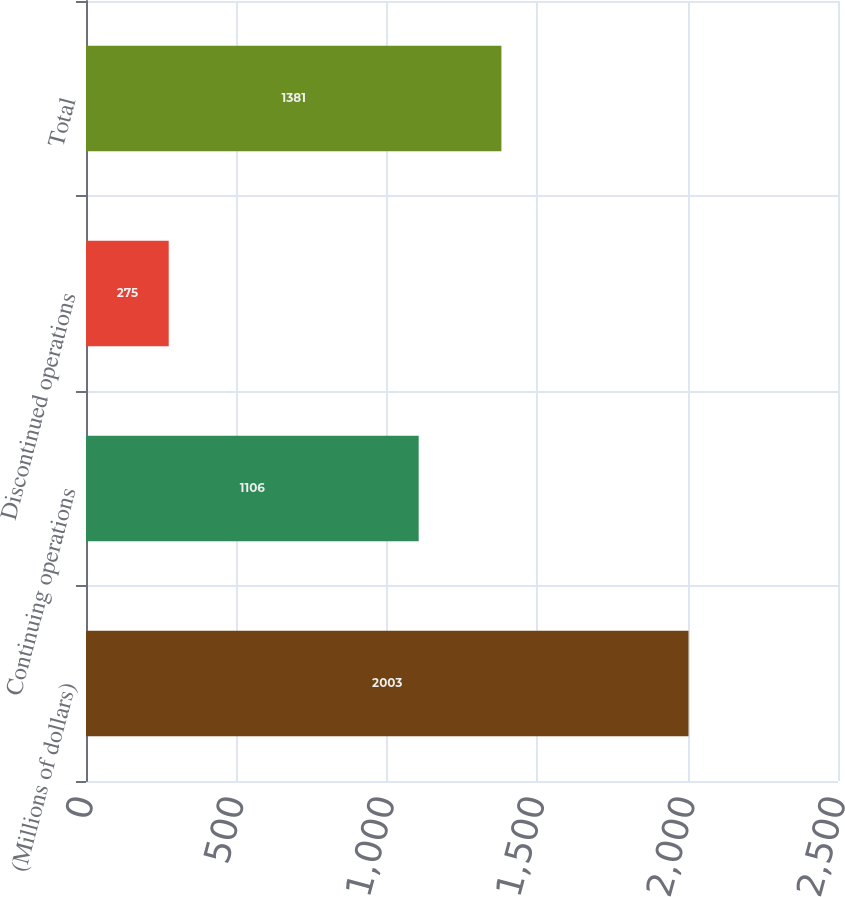Convert chart to OTSL. <chart><loc_0><loc_0><loc_500><loc_500><bar_chart><fcel>(Millions of dollars)<fcel>Continuing operations<fcel>Discontinued operations<fcel>Total<nl><fcel>2003<fcel>1106<fcel>275<fcel>1381<nl></chart> 